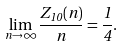<formula> <loc_0><loc_0><loc_500><loc_500>\lim _ { n \rightarrow \infty } \frac { Z _ { 1 0 } ( n ) } { n } = \frac { 1 } { 4 } .</formula> 